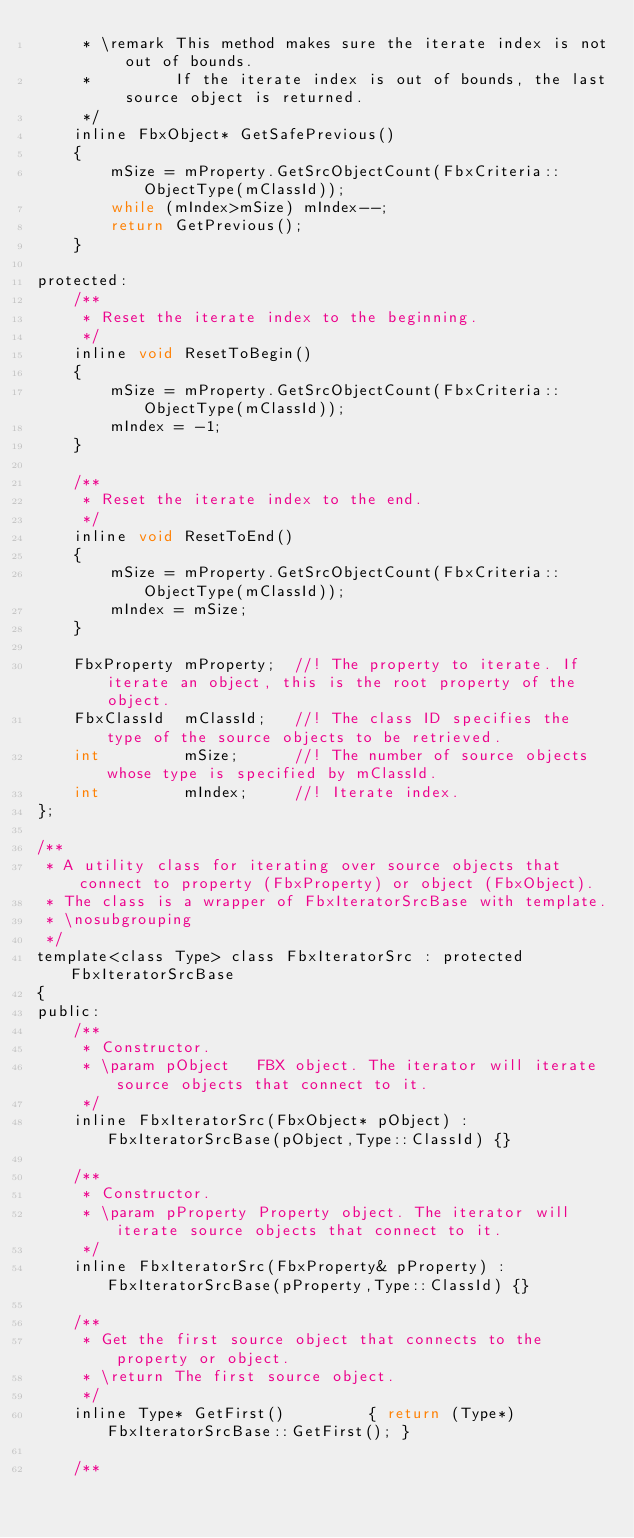Convert code to text. <code><loc_0><loc_0><loc_500><loc_500><_C_>	 * \remark This method makes sure the iterate index is not out of bounds.
	 *		   If the iterate index is out of bounds, the last source object is returned.
	 */
	inline FbxObject* GetSafePrevious()
	{
		mSize = mProperty.GetSrcObjectCount(FbxCriteria::ObjectType(mClassId));
		while (mIndex>mSize) mIndex--;
		return GetPrevious();
	}

protected:
	/**
	 * Reset the iterate index to the beginning.
	 */
	inline void ResetToBegin()
	{
		mSize = mProperty.GetSrcObjectCount(FbxCriteria::ObjectType(mClassId));
		mIndex = -1;
	}

	/**
	 * Reset the iterate index to the end.
	 */
	inline void ResetToEnd()
	{
		mSize = mProperty.GetSrcObjectCount(FbxCriteria::ObjectType(mClassId));
		mIndex = mSize;
	}

	FbxProperty	mProperty;	//! The property to iterate. If iterate an object, this is the root property of the object.
	FbxClassId	mClassId;	//! The class ID specifies the type of the source objects to be retrieved.
	int			mSize;		//! The number of source objects whose type is specified by mClassId.
	int			mIndex;		//! Iterate index.
};

/**
 * A utility class for iterating over source objects that connect to property (FbxProperty) or object (FbxObject).
 * The class is a wrapper of FbxIteratorSrcBase with template.
 * \nosubgrouping
 */
template<class Type> class FbxIteratorSrc : protected FbxIteratorSrcBase
{
public:
	/**
	 * Constructor.
	 * \param pObject	FBX object. The iterator will iterate source objects that connect to it.
	 */
    inline FbxIteratorSrc(FbxObject* pObject) : FbxIteratorSrcBase(pObject,Type::ClassId) {}
    
	/**
	 * Constructor.
	 * \param pProperty Property object. The iterator will iterate source objects that connect to it.
	 */
	inline FbxIteratorSrc(FbxProperty& pProperty) : FbxIteratorSrcBase(pProperty,Type::ClassId) {}

	/**
	 * Get the first source object that connects to the property or object.
	 * \return The first source object.
	 */
    inline Type* GetFirst()         { return (Type*)FbxIteratorSrcBase::GetFirst(); }
    
	/**</code> 